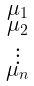Convert formula to latex. <formula><loc_0><loc_0><loc_500><loc_500>\begin{smallmatrix} \mu _ { 1 } \\ \mu _ { 2 } \\ \vdots \\ \mu _ { n } \end{smallmatrix}</formula> 